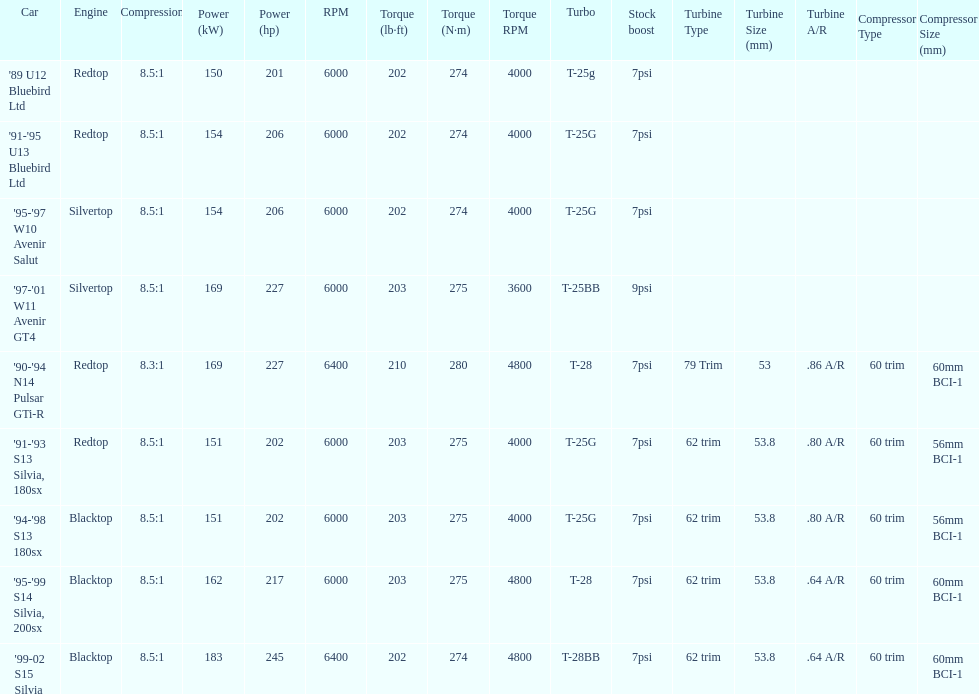Which car has a stock boost of over 7psi? '97-'01 W11 Avenir GT4. 